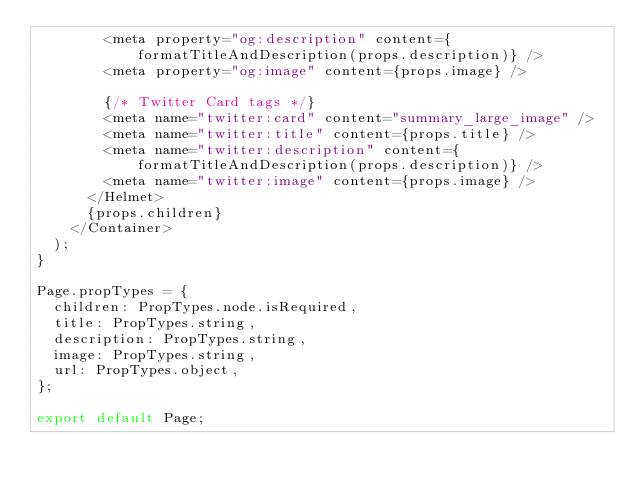Convert code to text. <code><loc_0><loc_0><loc_500><loc_500><_JavaScript_>        <meta property="og:description" content={formatTitleAndDescription(props.description)} />
        <meta property="og:image" content={props.image} />

        {/* Twitter Card tags */}
        <meta name="twitter:card" content="summary_large_image" />
        <meta name="twitter:title" content={props.title} />
        <meta name="twitter:description" content={formatTitleAndDescription(props.description)} />
        <meta name="twitter:image" content={props.image} />
      </Helmet>
      {props.children}
    </Container>
  );
}

Page.propTypes = {
  children: PropTypes.node.isRequired,
  title: PropTypes.string,
  description: PropTypes.string,
  image: PropTypes.string,
  url: PropTypes.object,
};

export default Page;
</code> 